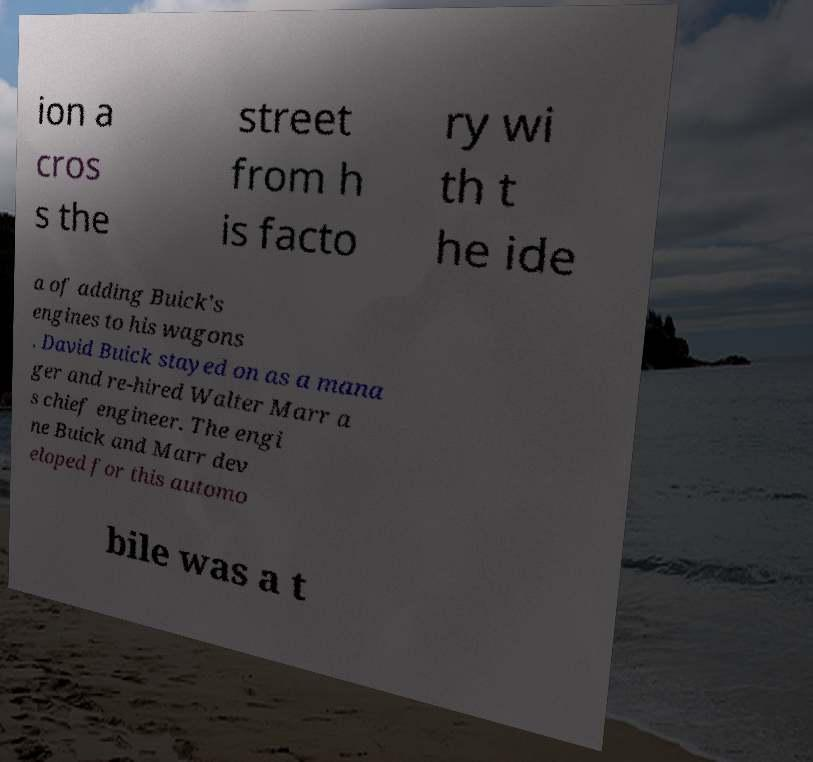There's text embedded in this image that I need extracted. Can you transcribe it verbatim? ion a cros s the street from h is facto ry wi th t he ide a of adding Buick's engines to his wagons . David Buick stayed on as a mana ger and re-hired Walter Marr a s chief engineer. The engi ne Buick and Marr dev eloped for this automo bile was a t 